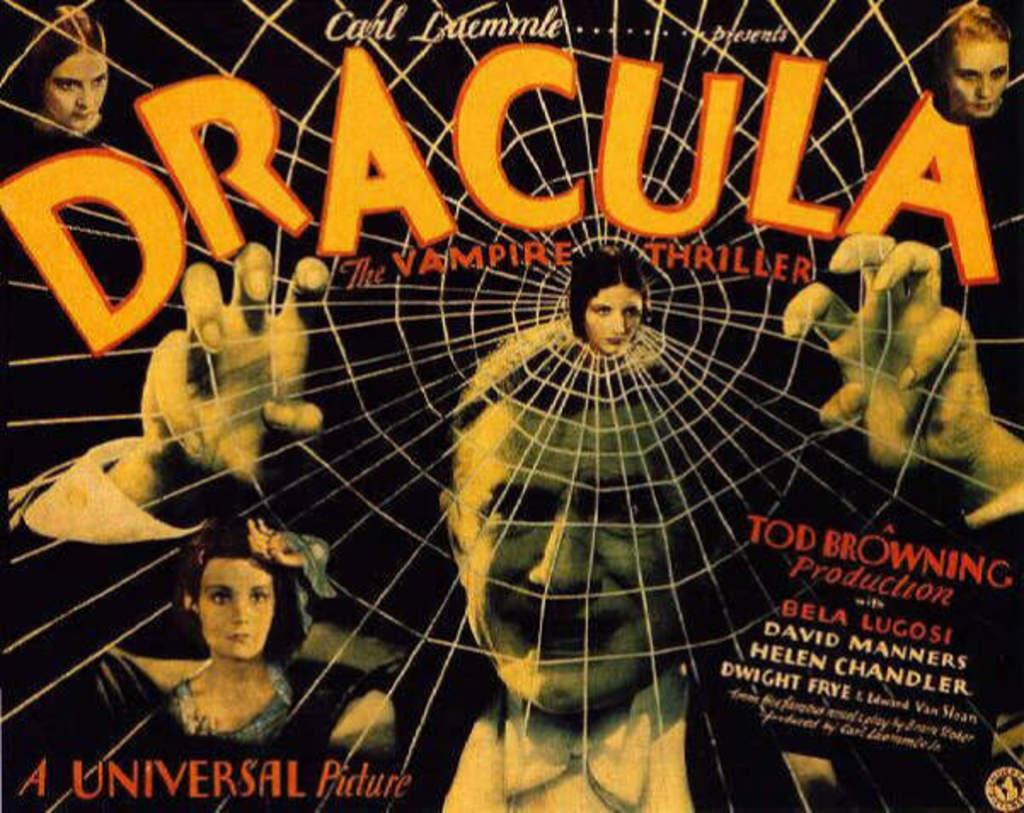Provide a one-sentence caption for the provided image. A poster showing Dracula with his hand lifted behind a spider web and other characters are shown around him. 